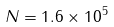Convert formula to latex. <formula><loc_0><loc_0><loc_500><loc_500>N = 1 . 6 \times 1 0 ^ { 5 }</formula> 